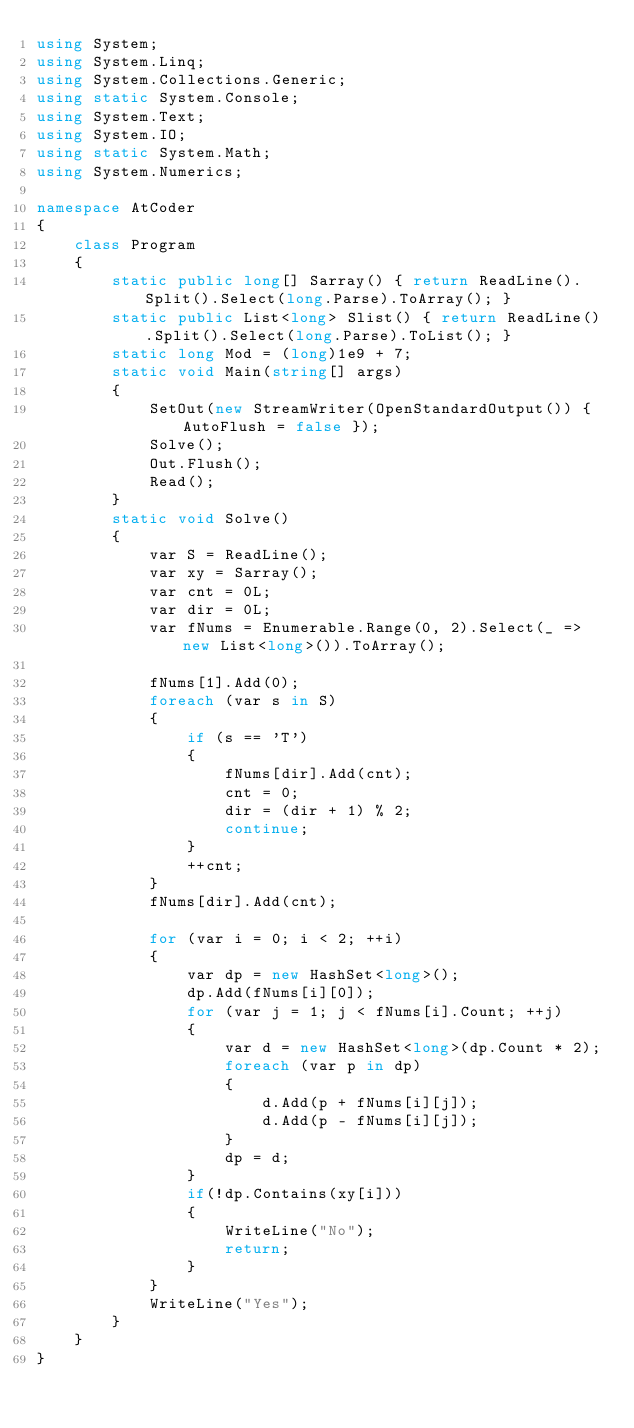Convert code to text. <code><loc_0><loc_0><loc_500><loc_500><_C#_>using System;
using System.Linq;
using System.Collections.Generic;
using static System.Console;
using System.Text;
using System.IO;
using static System.Math;
using System.Numerics;

namespace AtCoder
{
    class Program
    {
        static public long[] Sarray() { return ReadLine().Split().Select(long.Parse).ToArray(); }
        static public List<long> Slist() { return ReadLine().Split().Select(long.Parse).ToList(); }
        static long Mod = (long)1e9 + 7;
        static void Main(string[] args)
        {
            SetOut(new StreamWriter(OpenStandardOutput()) { AutoFlush = false });
            Solve();
            Out.Flush();
            Read();
        }
        static void Solve()
        {
            var S = ReadLine();
            var xy = Sarray();
            var cnt = 0L;
            var dir = 0L;
            var fNums = Enumerable.Range(0, 2).Select(_ => new List<long>()).ToArray();

            fNums[1].Add(0);
            foreach (var s in S)
            {
                if (s == 'T')
                {
                    fNums[dir].Add(cnt);
                    cnt = 0;
                    dir = (dir + 1) % 2;
                    continue;
                }
                ++cnt;
            }
            fNums[dir].Add(cnt);
            
            for (var i = 0; i < 2; ++i)
            {
                var dp = new HashSet<long>();
                dp.Add(fNums[i][0]);
                for (var j = 1; j < fNums[i].Count; ++j)
                {
                    var d = new HashSet<long>(dp.Count * 2);
                    foreach (var p in dp)
                    {
                        d.Add(p + fNums[i][j]);
                        d.Add(p - fNums[i][j]);
                    }
                    dp = d;
                }
                if(!dp.Contains(xy[i]))
                {
                    WriteLine("No");
                    return;
                }
            }
            WriteLine("Yes");
        }
    }
}</code> 